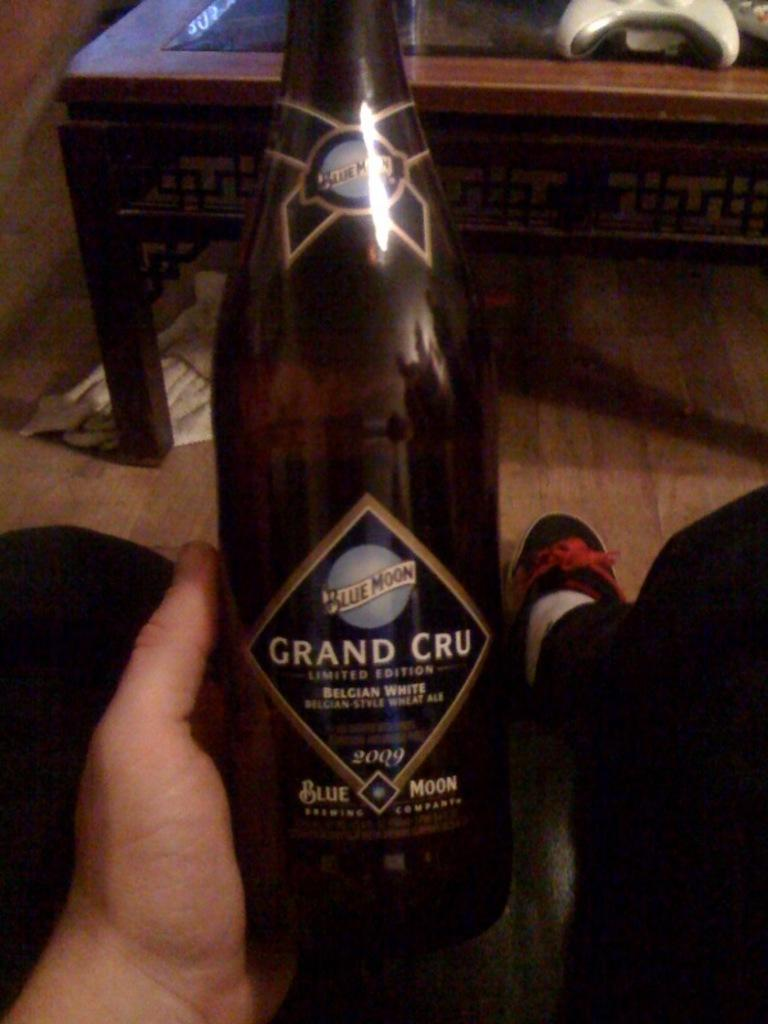<image>
Share a concise interpretation of the image provided. A bottle of beer with Grand Cru written on the label. 